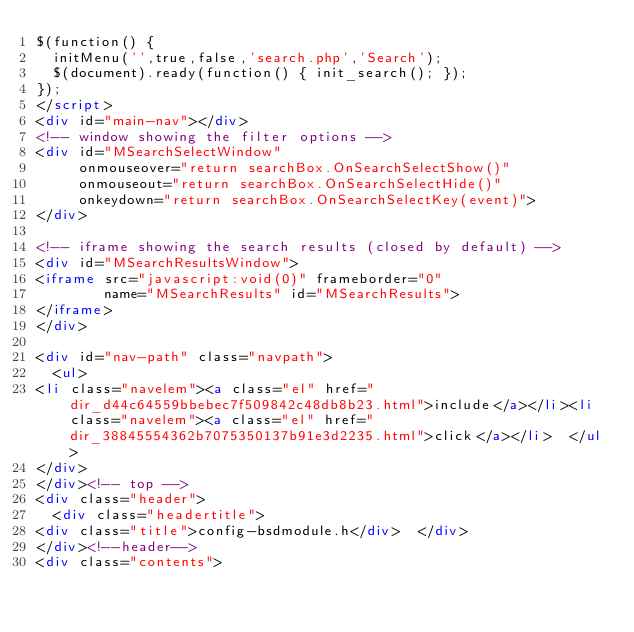Convert code to text. <code><loc_0><loc_0><loc_500><loc_500><_HTML_>$(function() {
  initMenu('',true,false,'search.php','Search');
  $(document).ready(function() { init_search(); });
});
</script>
<div id="main-nav"></div>
<!-- window showing the filter options -->
<div id="MSearchSelectWindow"
     onmouseover="return searchBox.OnSearchSelectShow()"
     onmouseout="return searchBox.OnSearchSelectHide()"
     onkeydown="return searchBox.OnSearchSelectKey(event)">
</div>

<!-- iframe showing the search results (closed by default) -->
<div id="MSearchResultsWindow">
<iframe src="javascript:void(0)" frameborder="0" 
        name="MSearchResults" id="MSearchResults">
</iframe>
</div>

<div id="nav-path" class="navpath">
  <ul>
<li class="navelem"><a class="el" href="dir_d44c64559bbebec7f509842c48db8b23.html">include</a></li><li class="navelem"><a class="el" href="dir_38845554362b7075350137b91e3d2235.html">click</a></li>  </ul>
</div>
</div><!-- top -->
<div class="header">
  <div class="headertitle">
<div class="title">config-bsdmodule.h</div>  </div>
</div><!--header-->
<div class="contents"></code> 